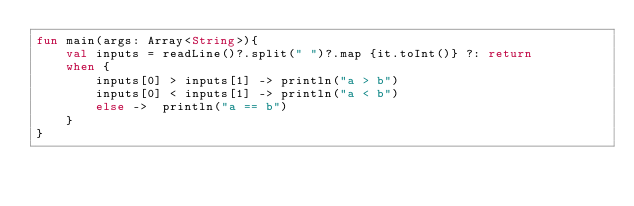Convert code to text. <code><loc_0><loc_0><loc_500><loc_500><_Kotlin_>fun main(args: Array<String>){
    val inputs = readLine()?.split(" ")?.map {it.toInt()} ?: return 
    when {
        inputs[0] > inputs[1] -> println("a > b") 
        inputs[0] < inputs[1] -> println("a < b")
        else ->  println("a == b")
    }
}
</code> 